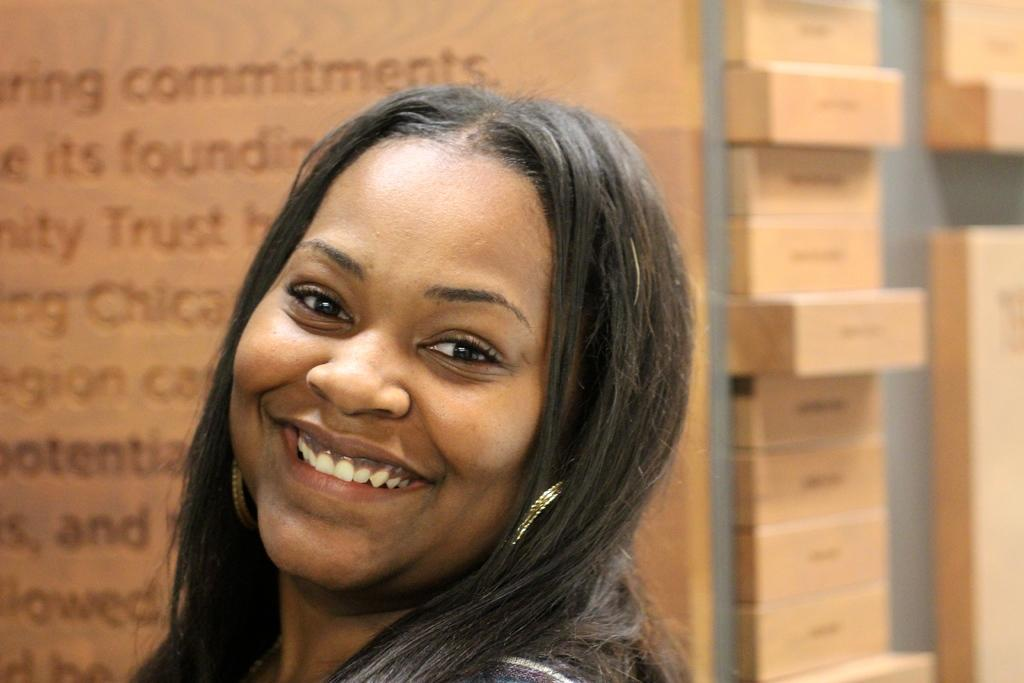What is present in the image? There is a person in the image. Can you describe the wooden surface in the image? There is text on a wooden surface in the image. What can be seen on the right side of the image? There are objects on the right side of the image. Are there any fairies visible in the image? No, there are no fairies present in the image. What type of vacation is the person in the image planning? The provided facts do not mention any vacation or travel plans, so it cannot be determined from the image. 